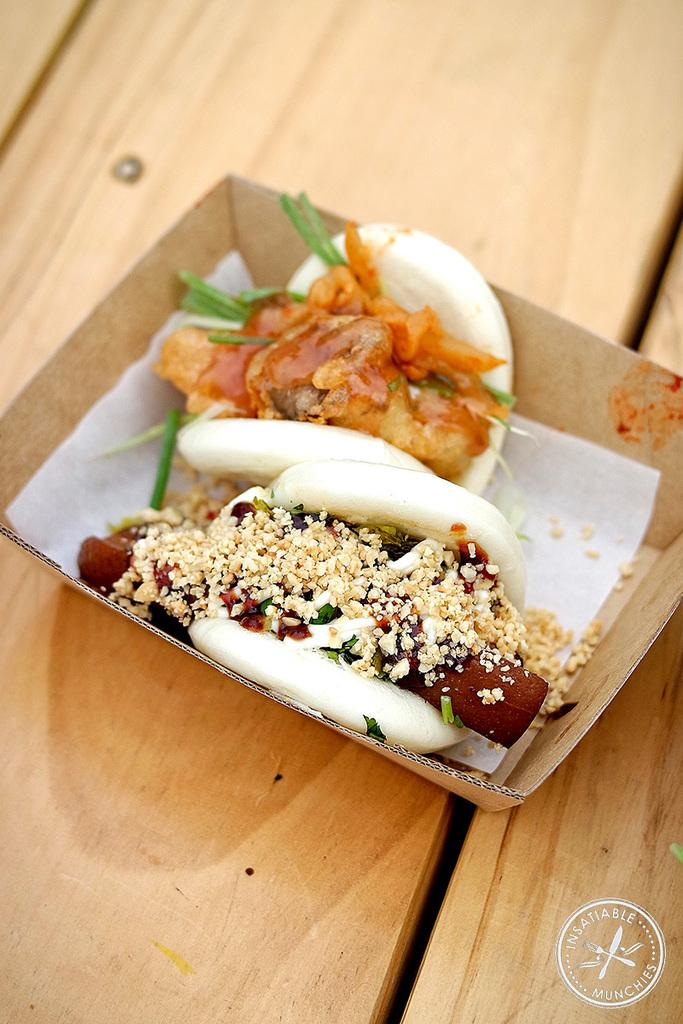What is the main subject of the image? The main subject of the image is food. How is the food arranged or presented in the image? The food is on a cardboard sheet. Where is the cardboard sheet with food placed? The cardboard sheet is placed on a table. How many spiders are crawling on the food in the image? There are no spiders present in the image; it only shows food on a cardboard sheet placed on a table. 